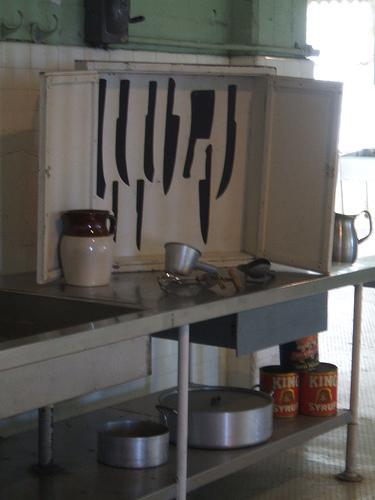Which one of these vegetables is used in the manufacture of the item in the cans? Please explain your reasoning. corn. The cans under the counter contain corn syrup that is made from corn. 